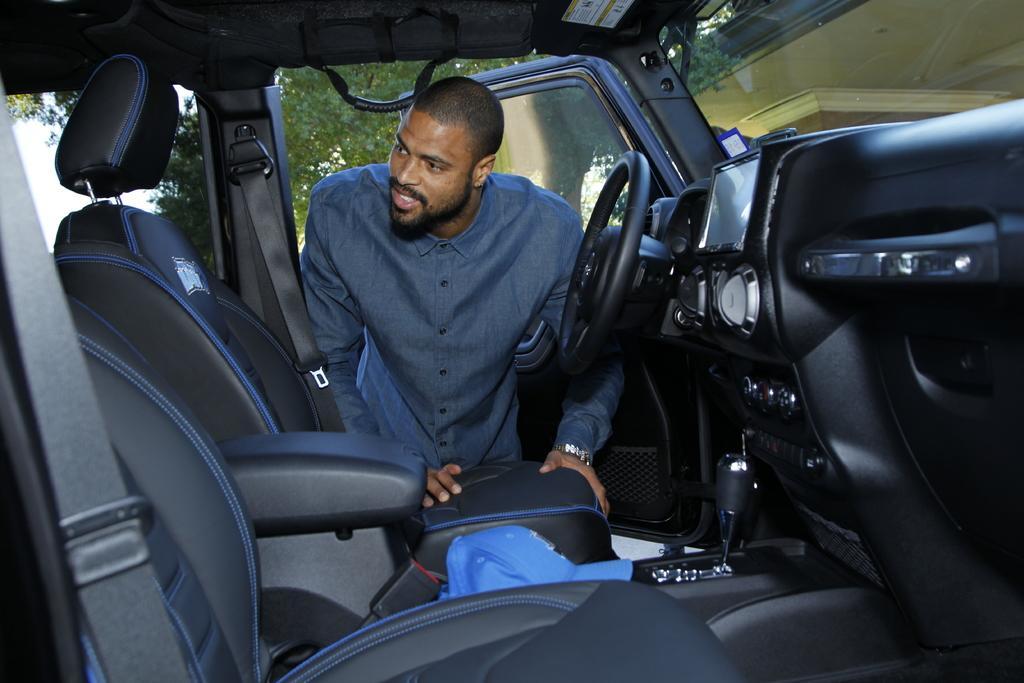Can you describe this image briefly? In this image there is a person standing at the car. At the right there is a building and at the back there is a tree. 